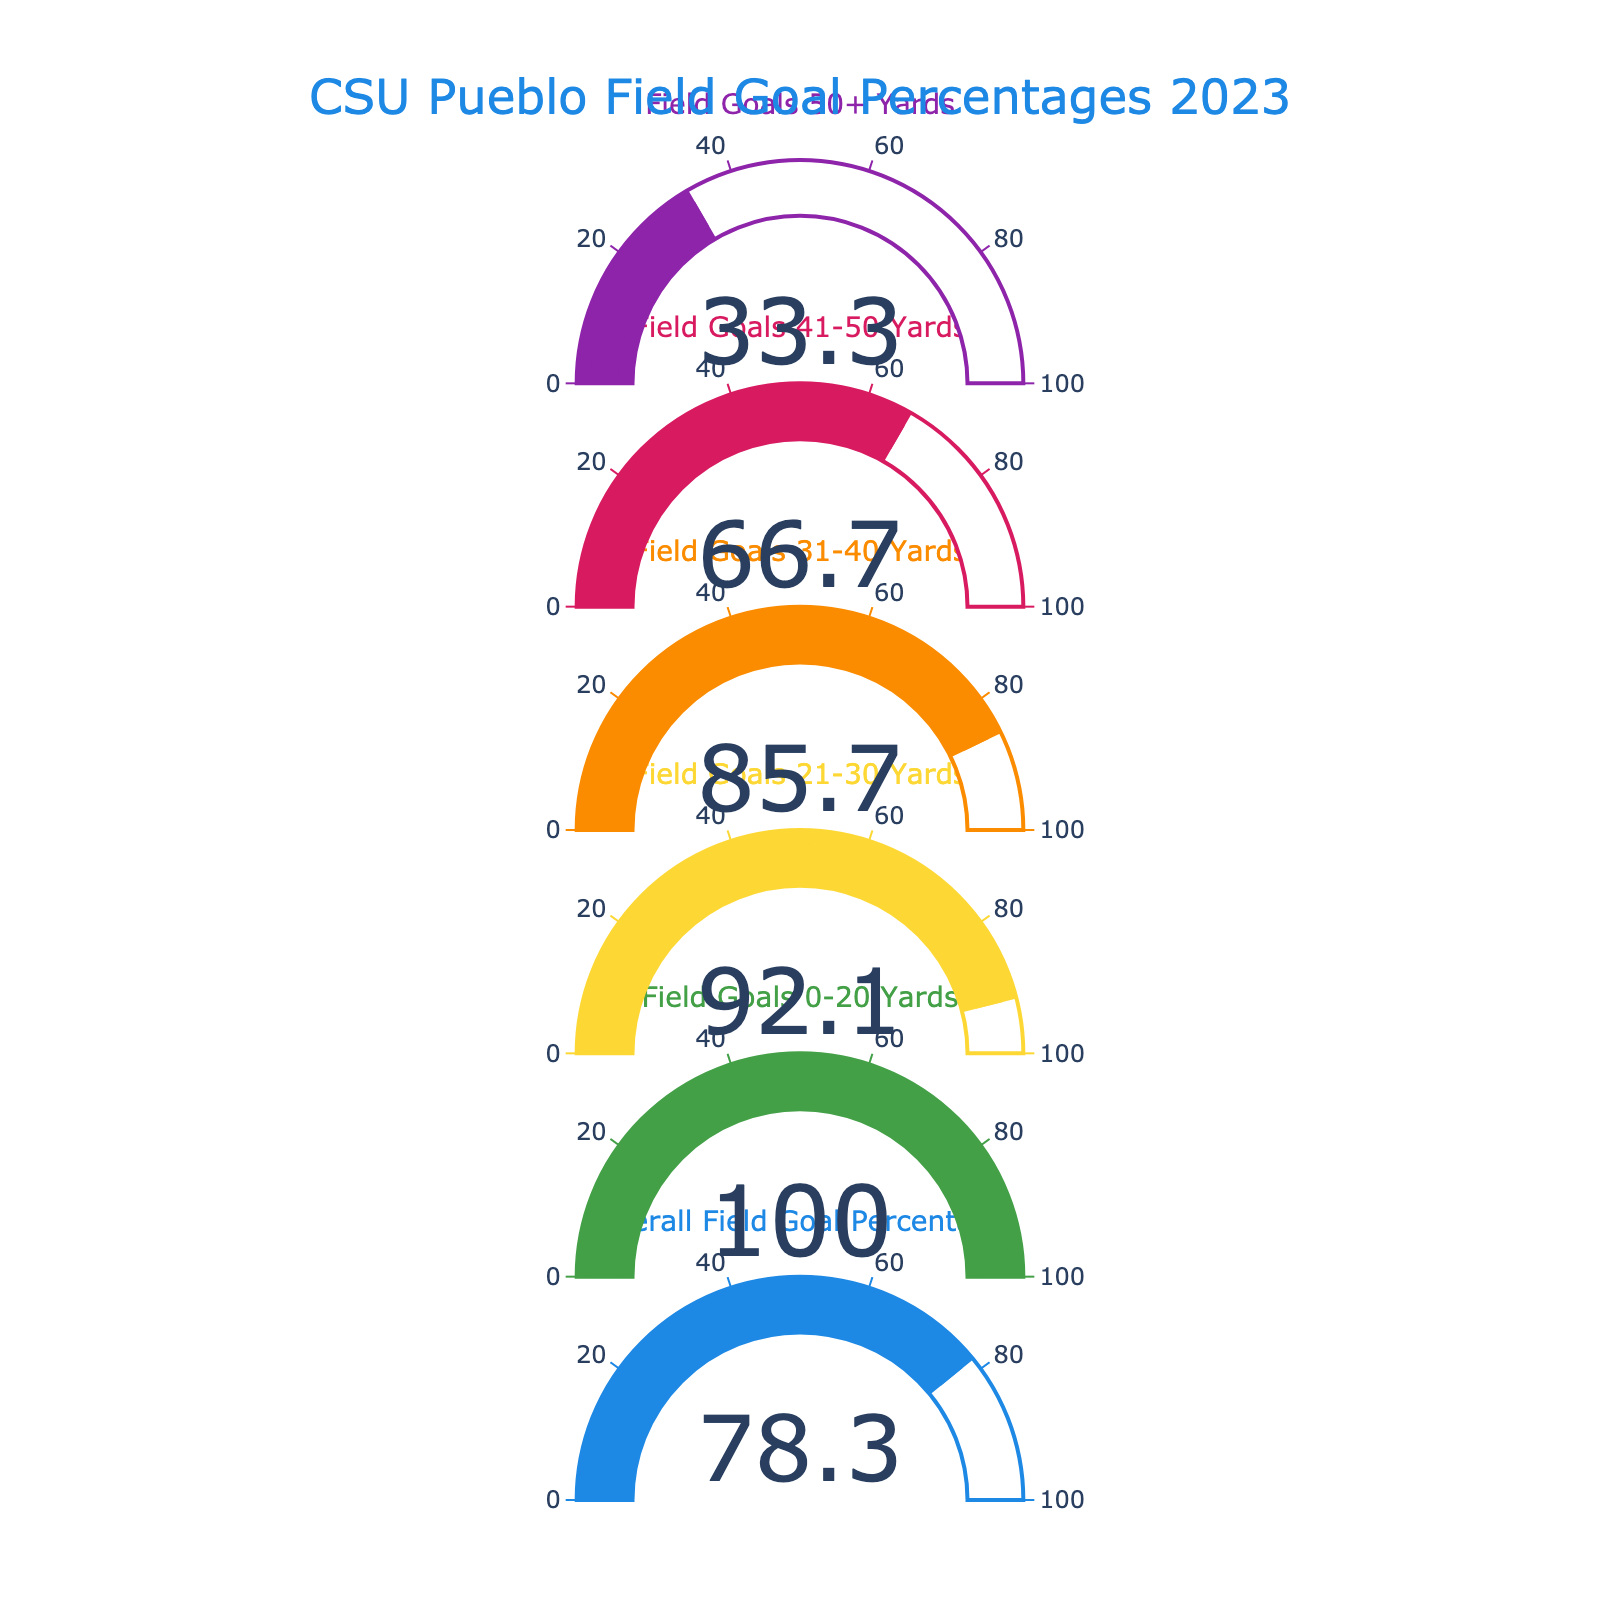What is the overall field goal percentage for CSU Pueblo in 2023? The overall field goal percentage is directly shown on the gauge chart.
Answer: 78.3% What percentage of field goals from 0-20 yards was successful? The successful field goal percentage for 0-20 yards is displayed on the gauge chart.
Answer: 100.0% Which category has the lowest field goal success percentage? By comparing all the percentages displayed on the gauges, the one with the lowest value is for field goals from 50+ yards.
Answer: 33.3% How much higher is the success rate for field goals from 21-30 yards compared to field goals from 41-50 yards? Subtract the percentage for field goals from 41-50 yards from the percentage for field goals from 21-30 yards: 92.1% - 66.7%.
Answer: 25.4% Which category has the second-highest percentage of successful field goals? After the 0-20 yards category with the highest success rate, the next highest is for 21-30 yards.
Answer: 92.1% What is the total number of categories displayed in the gauge chart? Count the number of separate gauges displayed.
Answer: 6 What percentage of field goals from 31-40 yards was successful? The percentage for field goals from 31-40 yards is shown on the gauge chart.
Answer: 85.7% Which success rate is closer to the overall field goal percentage: 31-40 yards or 41-50 yards? Compare the difference between the overall percentage (78.3%) with the percentages of 31-40 yards (85.7%) and 41-50 yards (66.7%).
Answer: 41-50 yards What is the average success percentage for field goals from 21-30 yards and 31-40 yards? Add the percentages and divide by 2: (92.1% + 85.7%) / 2.
Answer: 88.9% How does the success rate for field goals over 50 yards compare to the success rate for those under 21 yards? Subtract the percentage of field goals over 50 yards from the percentage of field goals under 21 yards: 100.0% - 33.3%.
Answer: 66.7% 